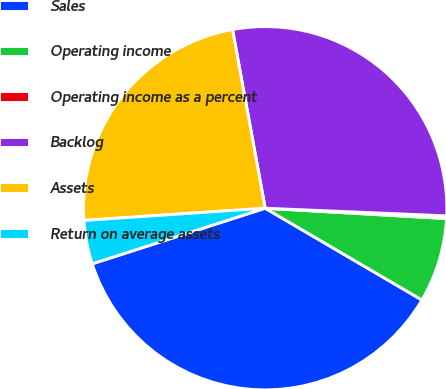Convert chart. <chart><loc_0><loc_0><loc_500><loc_500><pie_chart><fcel>Sales<fcel>Operating income<fcel>Operating income as a percent<fcel>Backlog<fcel>Assets<fcel>Return on average assets<nl><fcel>36.62%<fcel>7.52%<fcel>0.24%<fcel>28.55%<fcel>23.19%<fcel>3.88%<nl></chart> 